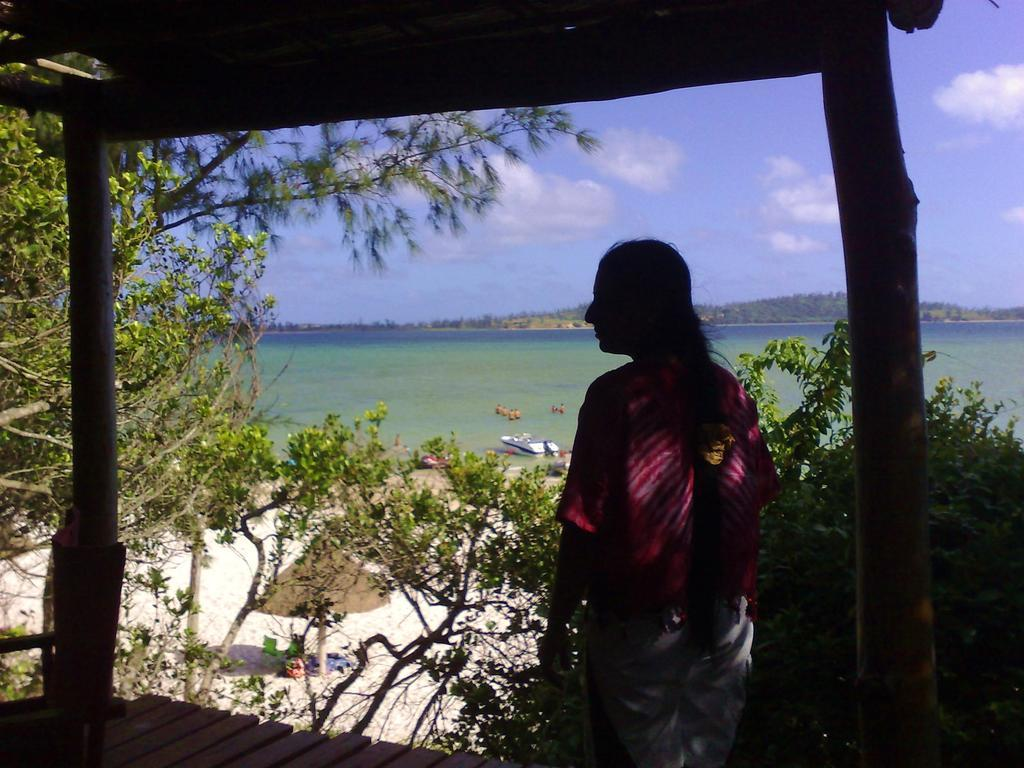What is the main subject of the image? There is a person standing in the image. What can be seen in the foreground of the image? Wooden poles and trees are visible in the image. What is on the ground in the image? There are objects on the ground in the image. What is visible in the background of the image? There is a boat on the water and the sky in the background of the image. What type of relation does the person have with the women in the image? There are no women present in the image, so it is not possible to determine any relation. 